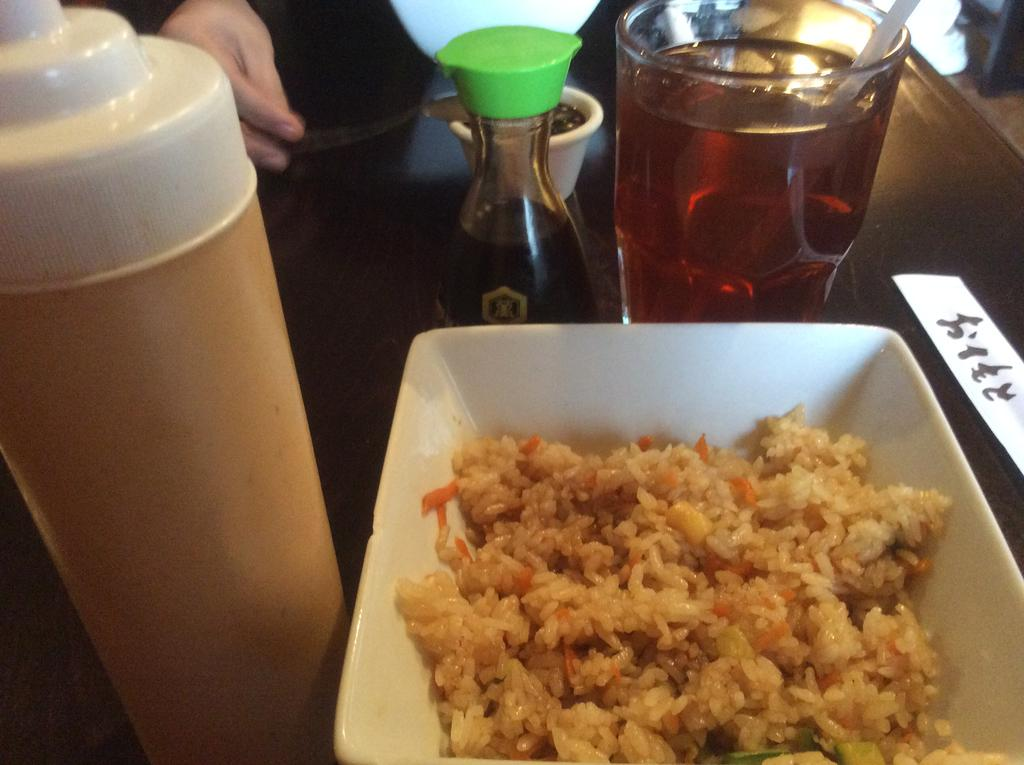What piece of furniture is present in the image? There is a table in the image. What can be found on the table? There is food and a glass on the table. What else is on the table? There is also a bottle on the table. Whose hand is visible in the image? A person's hand is visible in the image. Where is the sink located in the image? There is no sink present in the image. What type of rose is being held by the person in the image? There is no rose present in the image. 